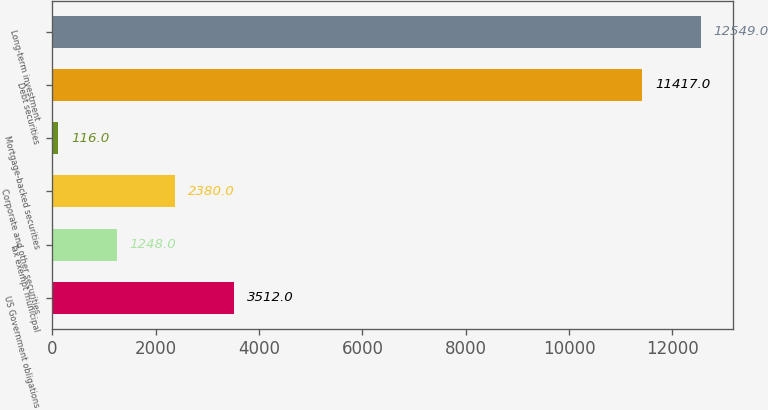Convert chart to OTSL. <chart><loc_0><loc_0><loc_500><loc_500><bar_chart><fcel>US Government obligations<fcel>Tax exempt municipal<fcel>Corporate and other securities<fcel>Mortgage-backed securities<fcel>Debt securities<fcel>Long-term investment<nl><fcel>3512<fcel>1248<fcel>2380<fcel>116<fcel>11417<fcel>12549<nl></chart> 